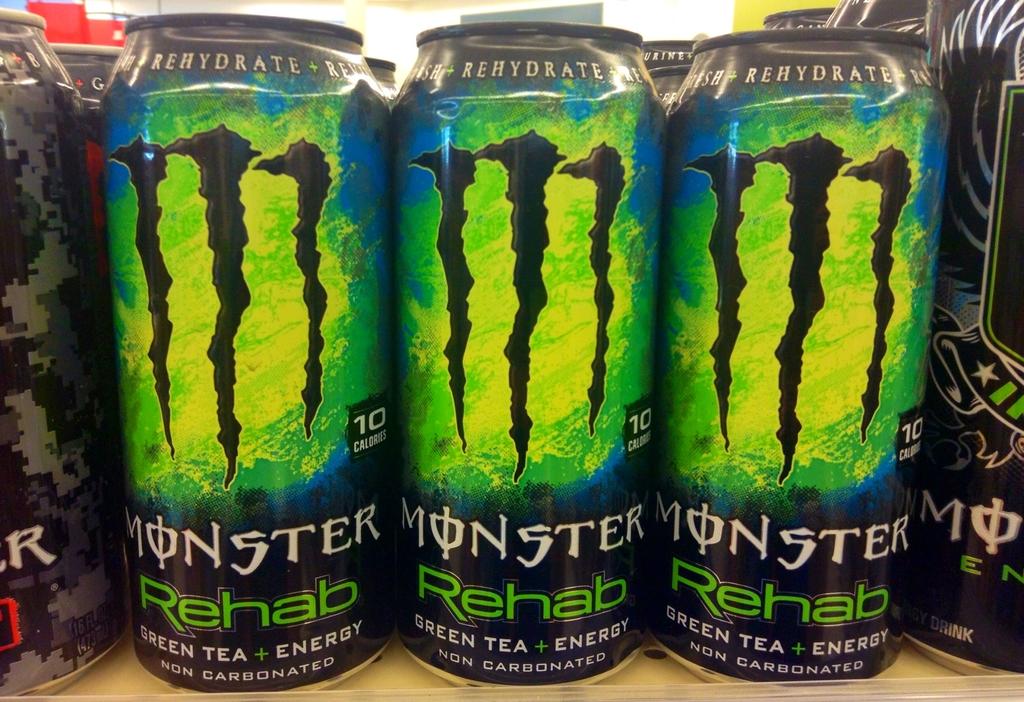What kind of tea is this drink?
Ensure brevity in your answer.  Green tea. Who makes monster rehab energy drink?
Offer a terse response. Monster. 